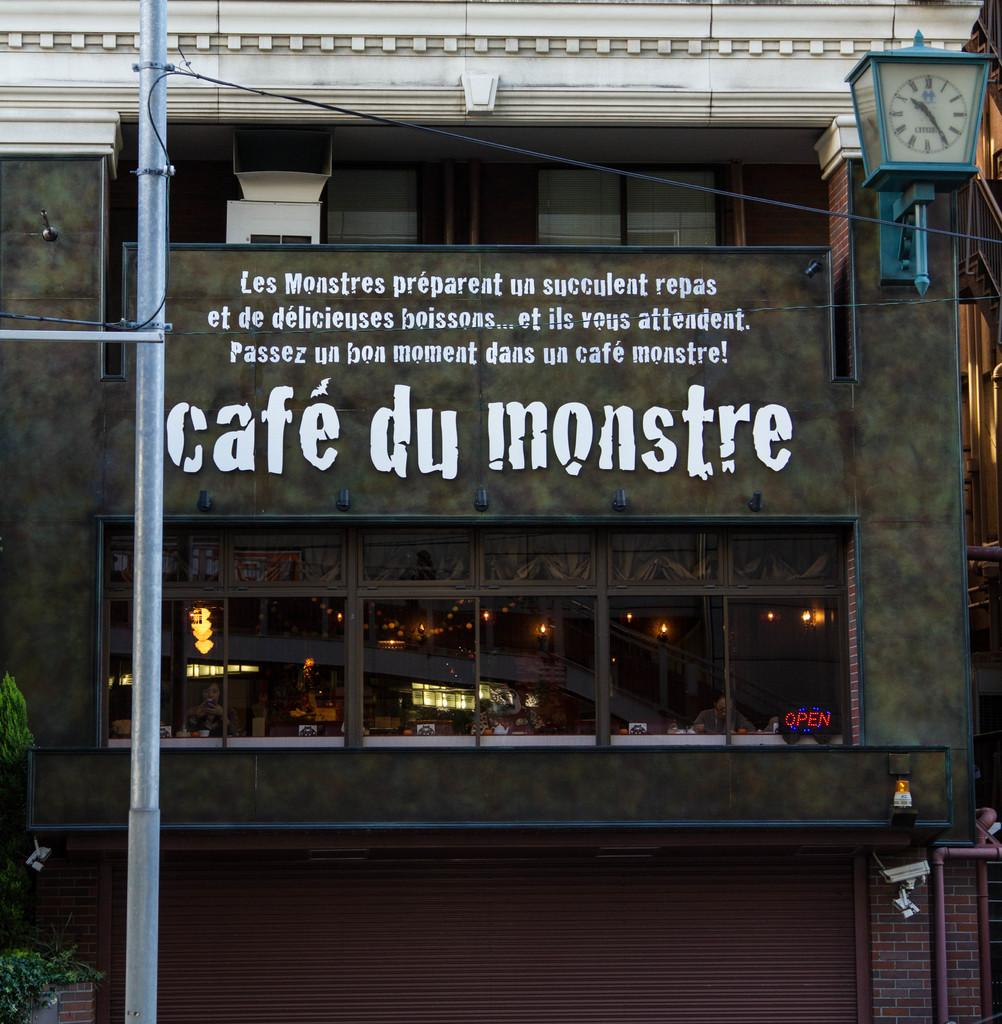What type of structure can be seen in the image? There is a building in the image. What else is present in the image besides the building? There is a pole, wires, a cloth, some text, lights, plants, and rods in the image. Can you describe the pole in the image? The pole is a vertical structure that supports the wires. What might the text in the image be used for? The text in the image could be used for identification, advertisement, or information purposes. What type of vegetation is present in the image? There are plants in the image. What type of clam is being used as a decoration on the building in the image? There are no clams present in the image; it features a building, pole, wires, cloth, text, lights, plants, and rods. What type of berry can be seen growing on the plants in the image? There is no mention of berries in the image; it only states that there are plants present. 